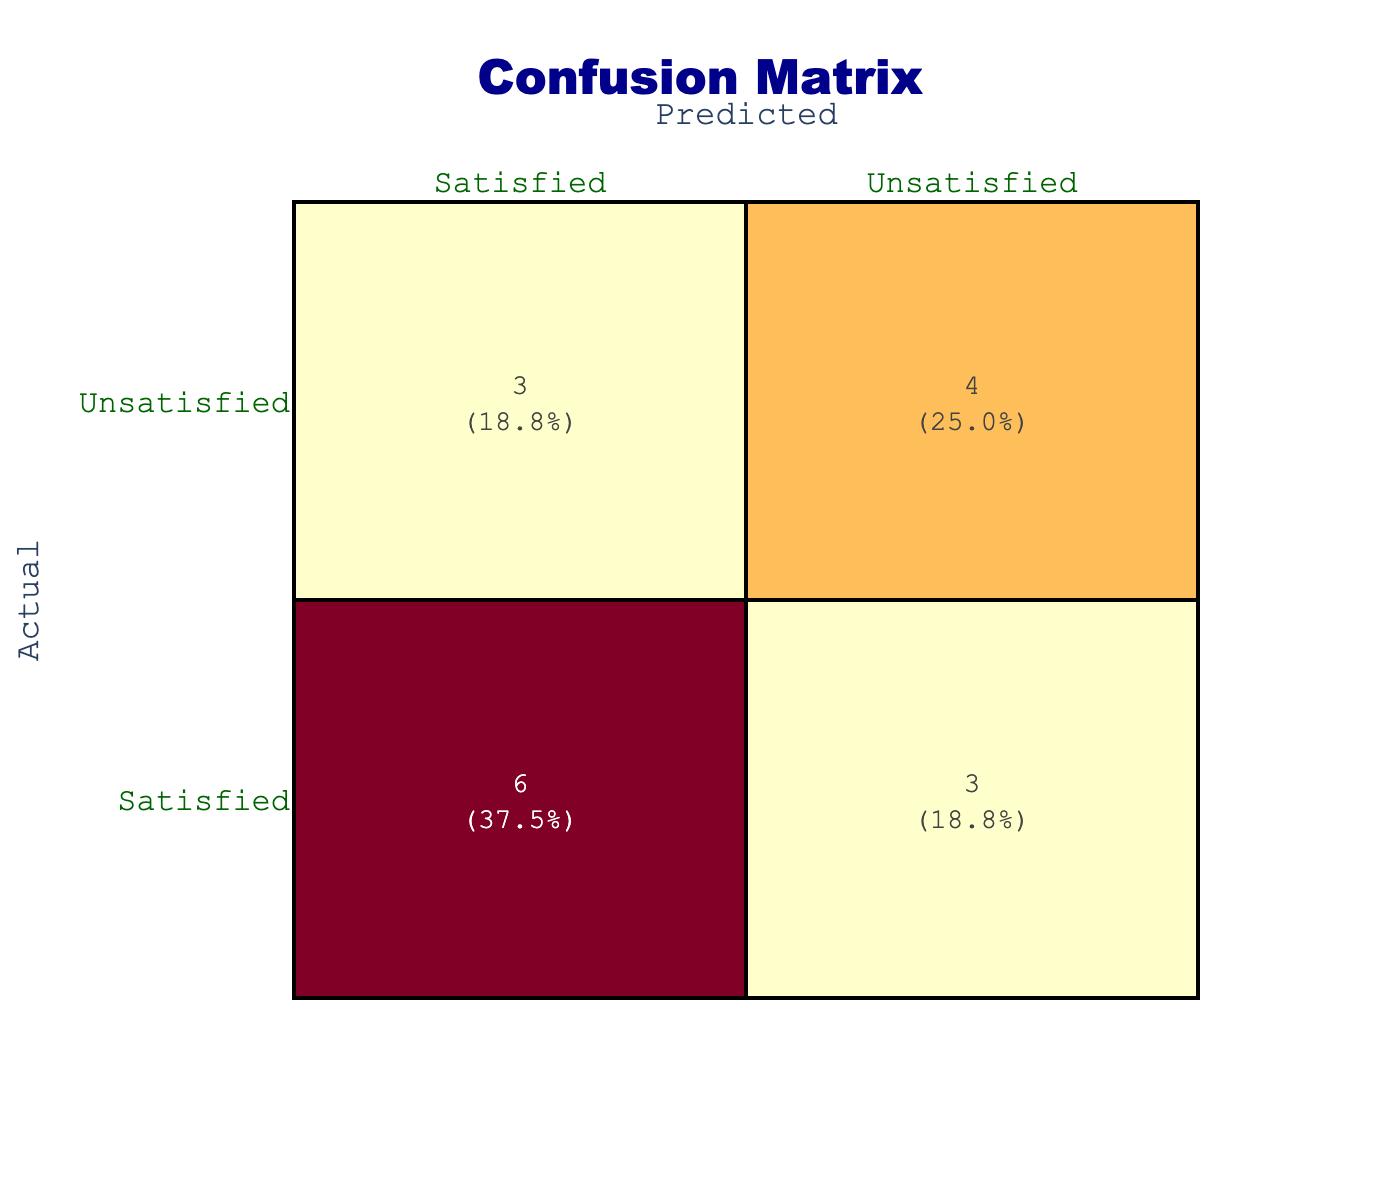What is the total number of satisfied customers according to the actual data? By examining the actual satisfaction row, we find the entries labeled "Satisfied." There are 10 occurrences of "Satisfied" out of 16 total responses.
Answer: 10 What percentage of the predictions accurately reflected customer satisfaction? The correct predictions occur in two categories: Satisfied to Satisfied (8) and Unsatisfied to Unsatisfied (5). Counting these, we have 8 + 5 = 13 correct predictions out of 16 total entries. The percentage is calculated as (13/16) * 100 = 81.3%.
Answer: 81.3% Is there a higher count of predicted satisfied customers compared to predicted unsatisfied customers? Counting the predicted "Satisfied" entries (8) and predicted "Unsatisfied" entries (8) gives us equal counts, indicating that the number of predicted satisfied customers is not higher.
Answer: No How many customers were incorrectly predicted as satisfied? To find this, we look for cases where actual customers were unsatisfied but predicted as satisfied. Those counts show that there were 3 such incorrect predictions.
Answer: 3 What is the ratio of unsatisfied customers to satisfied customers in the actual data? The actual data shows 10 satisfied customers and 6 unsatisfied customers. The ratio is calculated by dividing the number of unsatisfied by satisfied, which gives us 6:10 or simplified, 3:5.
Answer: 3:5 What is the difference between the number of satisfied predictions and unsatisfied predictions? Upon counting the satisfied predictions (8) and unsatisfied predictions (8), we see that they are equal. The difference is calculated by subtracting unsatisfied from satisfied, which yields 0.
Answer: 0 Are more customers satisfied than unsatisfied in actual data? Looking at the actual satisfaction numbers, there are 10 satisfied and 6 unsatisfied customers. Since 10 is greater than 6, we can affirmatively say more customers are satisfied than unsatisfied.
Answer: Yes What steps can be taken to improve the accuracy of predictions if customers are predominantly satisfied? Referring to the confusion matrix, one approach could be to analyze false predictions and enhance the model predictions by implementing more targeted customer surveys or adjusting model parameters to reflect the satisfaction bias better.
Answer: Implement targeted surveys and refine model parameters 